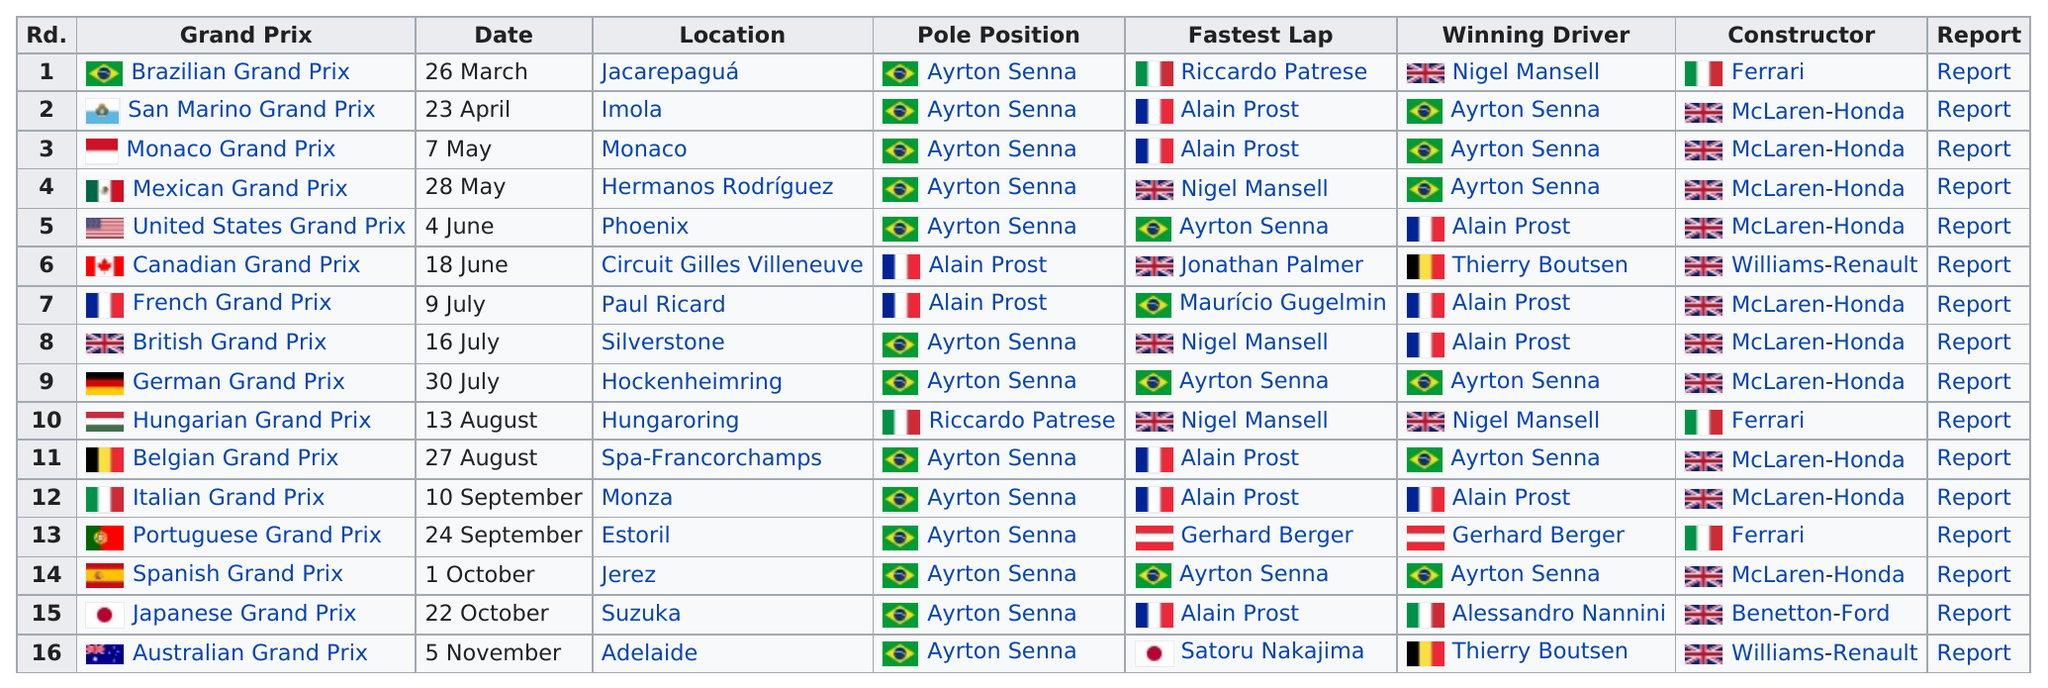Draw attention to some important aspects in this diagram. Ayrton Senna holds the record for the most pole positions with a total of 13. Satoru Nakajima achieved the fastest lap in the previous season's grand prix. Ayrton Senna was the winning driver in three consecutive races in a row. Ayrton Senna holds the record for having the most pole positions, with the most number of times holding pole position. In this season, a total of 16 grand prix events were held. 